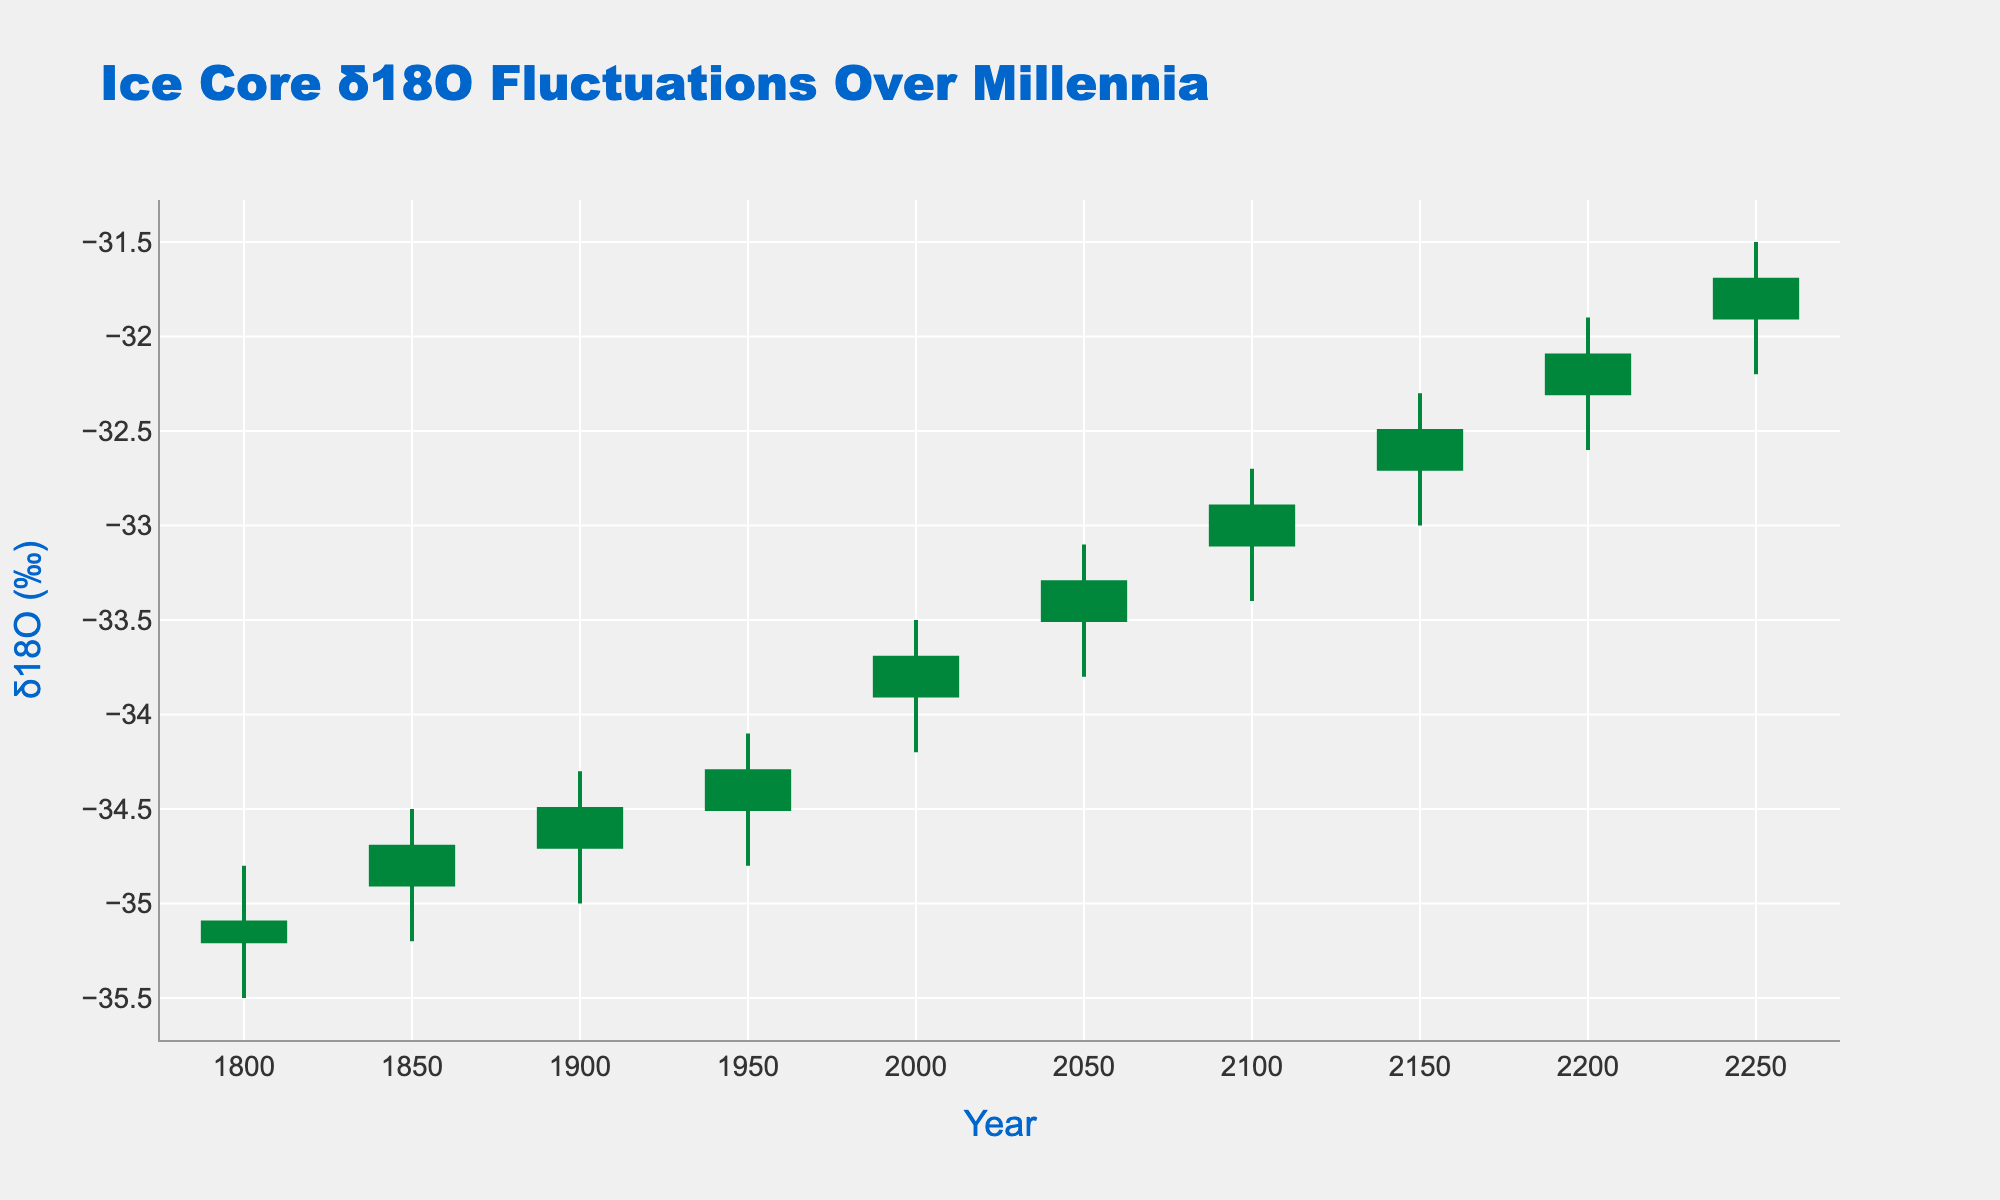What is the range of years shown in the figure? The x-axis of the figure represents the years, starting from 1800 and ending in 2250. This range can be observed directly by looking at the beginning and end labels on the x-axis.
Answer: 1800 to 2250 What does the title of the figure indicate? The title of the figure is "Ice Core δ18O Fluctuations Over Millennia." This indicates that the figure shows variations in oxygen isotope ratios (δ18O) in ice cores over a long period, in this case, millennia.
Answer: Ice Core δ18O Fluctuations Over Millennia What is the δ18O (‰) value at the year 2000? By looking at the open, high, low, and close values for the year 2000 on the OHLC chart, we can see that the close value is -33.7. This is the value of δ18O (‰) at that point in time.
Answer: -33.7 Which year had the highest δ18O (‰) high value? The year with the highest value can be found by checking the high points of the candlestick plot. The highest δ18O (‰) high value is -31.5, observed in the year 2250.
Answer: 2250 What is the average close value of δ18O (‰) over the years listed? To find the average close value, add up all the close values (-35.1, -34.7, -34.5, -34.3, -33.7, -33.3, -32.9, -32.5, -32.1, -31.7) and divide by the number of years (10). The sum is -334.8, so the average is -334.8 / 10 = -33.48.
Answer: -33.48 How many years show an increasing trend in δ18O (‰) values based on the candlestick color? An increasing trend is indicated by green candlesticks. By counting these in the plot, we see 6 candlesticks (years: 1850, 1900, 1950, 2000, 2100, 2200).
Answer: 6 Compare the δ18O (‰) values in the years 1800 and 1850. Which year had a higher high value? By looking at the high values for these years, 1800 had a high of -34.8, and 1850 had a high of -34.5. Therefore, 1850 had a higher high value.
Answer: 1850 What is the overall trend in δ18O (‰) values from 1800 to 2250? Observing the candlestick plot, it is evident that the δ18O (‰) values show a general increasing trend from 1800 (-35.2 to -35.1) to 2250 (-31.9 to -31.7). The values become less negative over time, indicating a general warming trend.
Answer: Increasing trend What is the difference in δ18O (‰) low values between the years 1950 and 2200? The low value for 1950 is -34.8 and for 2200 is -32.6. The difference is calculated by subtracting the low value of 2200 from that of 1950: -34.8 - (-32.6) = -2.2.
Answer: -2.2 During which interval do the δ18O (‰) values show the most significant increase? Observing the candlestick plots, the steepest increase can be identified between 2000 (-33.9 to -33.7) and 2050 (-33.5 to -33.3), showing the largest change.
Answer: 2050 